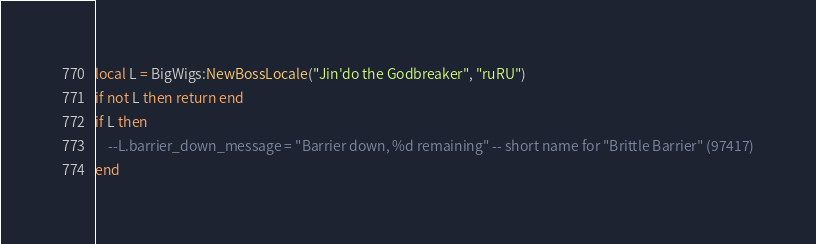<code> <loc_0><loc_0><loc_500><loc_500><_Lua_>local L = BigWigs:NewBossLocale("Jin'do the Godbreaker", "ruRU")
if not L then return end
if L then
	--L.barrier_down_message = "Barrier down, %d remaining" -- short name for "Brittle Barrier" (97417)
end
</code> 